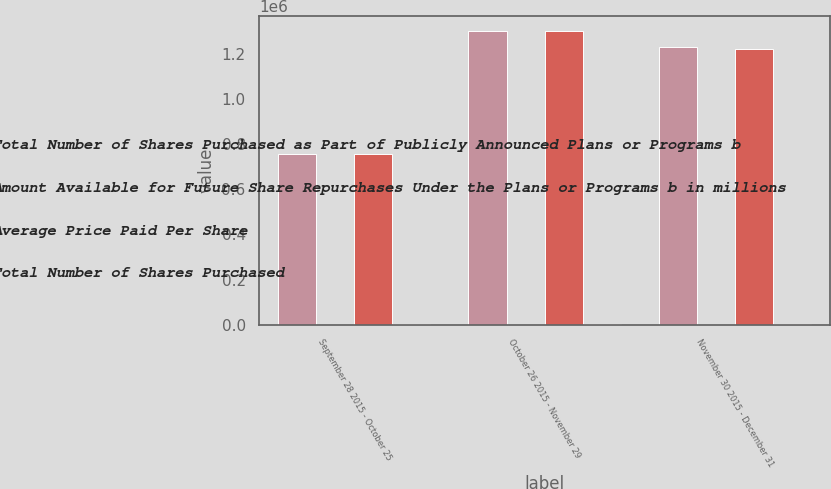Convert chart. <chart><loc_0><loc_0><loc_500><loc_500><stacked_bar_chart><ecel><fcel>September 28 2015 - October 25<fcel>October 26 2015 - November 29<fcel>November 30 2015 - December 31<nl><fcel>Total Number of Shares Purchased as Part of Publicly Announced Plans or Programs b<fcel>754286<fcel>1.30034e+06<fcel>1.23135e+06<nl><fcel>Amount Available for Future Share Repurchases Under the Plans or Programs b in millions<fcel>208.57<fcel>218.87<fcel>217.27<nl><fcel>Average Price Paid Per Share<fcel>754004<fcel>1.30007e+06<fcel>1.22181e+06<nl><fcel>Total Number of Shares Purchased<fcel>4150<fcel>3866<fcel>3600<nl></chart> 